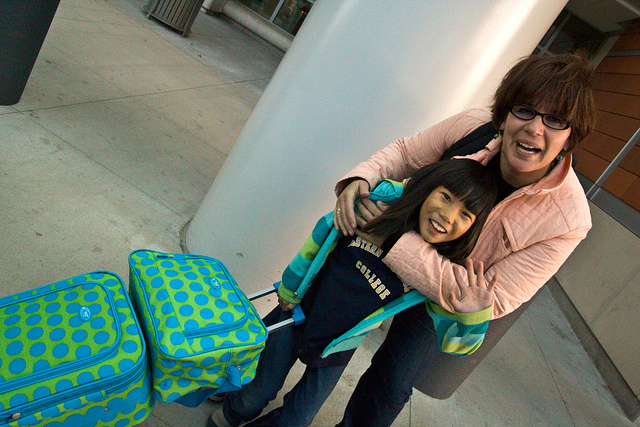How do the people in the photo seem to feel about their upcoming trip? The people in the photo emanate a sense of excitement and joy, as indicated by their smiles and cheerful body language. Their positive emotions suggest they are looking forward to the trip and the experiences they are about to have. 